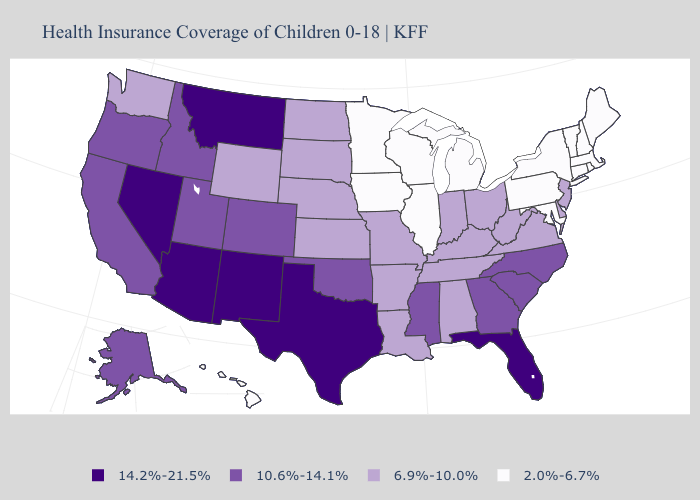What is the highest value in the USA?
Answer briefly. 14.2%-21.5%. Does New Jersey have a lower value than Montana?
Answer briefly. Yes. Name the states that have a value in the range 14.2%-21.5%?
Give a very brief answer. Arizona, Florida, Montana, Nevada, New Mexico, Texas. Which states have the highest value in the USA?
Write a very short answer. Arizona, Florida, Montana, Nevada, New Mexico, Texas. Which states have the lowest value in the USA?
Give a very brief answer. Connecticut, Hawaii, Illinois, Iowa, Maine, Maryland, Massachusetts, Michigan, Minnesota, New Hampshire, New York, Pennsylvania, Rhode Island, Vermont, Wisconsin. Does the first symbol in the legend represent the smallest category?
Be succinct. No. What is the lowest value in states that border New York?
Write a very short answer. 2.0%-6.7%. Does Delaware have the lowest value in the USA?
Concise answer only. No. How many symbols are there in the legend?
Be succinct. 4. Does the map have missing data?
Write a very short answer. No. What is the value of Hawaii?
Keep it brief. 2.0%-6.7%. Does the map have missing data?
Quick response, please. No. Name the states that have a value in the range 2.0%-6.7%?
Concise answer only. Connecticut, Hawaii, Illinois, Iowa, Maine, Maryland, Massachusetts, Michigan, Minnesota, New Hampshire, New York, Pennsylvania, Rhode Island, Vermont, Wisconsin. What is the highest value in the South ?
Write a very short answer. 14.2%-21.5%. Among the states that border Idaho , which have the highest value?
Write a very short answer. Montana, Nevada. 